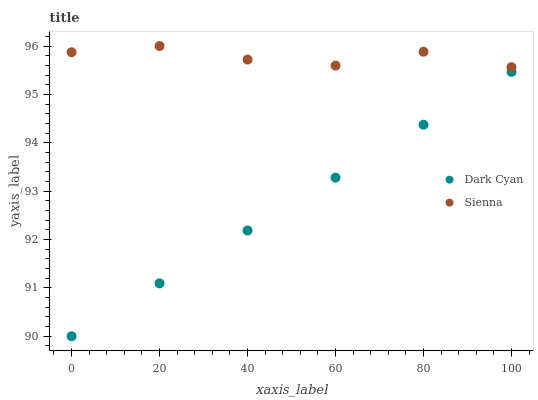Does Dark Cyan have the minimum area under the curve?
Answer yes or no. Yes. Does Sienna have the maximum area under the curve?
Answer yes or no. Yes. Does Sienna have the minimum area under the curve?
Answer yes or no. No. Is Dark Cyan the smoothest?
Answer yes or no. Yes. Is Sienna the roughest?
Answer yes or no. Yes. Is Sienna the smoothest?
Answer yes or no. No. Does Dark Cyan have the lowest value?
Answer yes or no. Yes. Does Sienna have the lowest value?
Answer yes or no. No. Does Sienna have the highest value?
Answer yes or no. Yes. Is Dark Cyan less than Sienna?
Answer yes or no. Yes. Is Sienna greater than Dark Cyan?
Answer yes or no. Yes. Does Dark Cyan intersect Sienna?
Answer yes or no. No. 